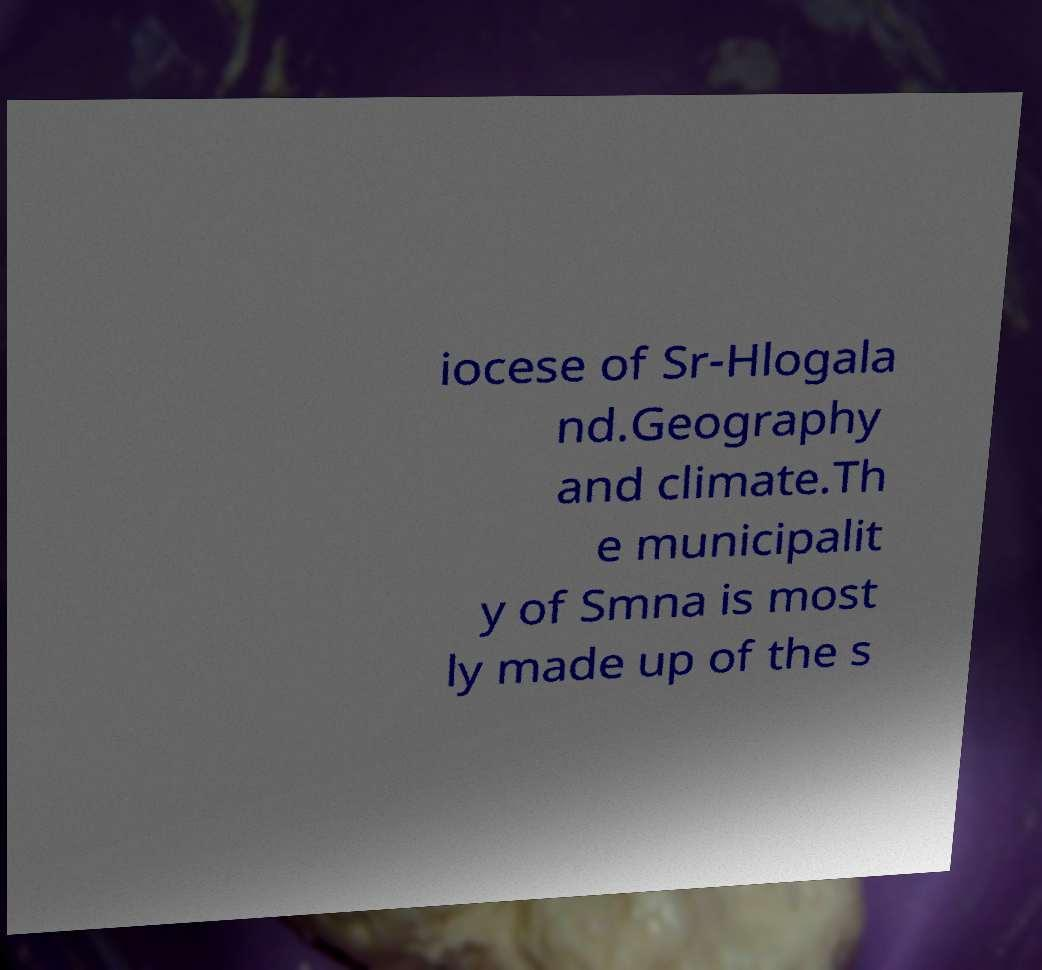There's text embedded in this image that I need extracted. Can you transcribe it verbatim? iocese of Sr-Hlogala nd.Geography and climate.Th e municipalit y of Smna is most ly made up of the s 